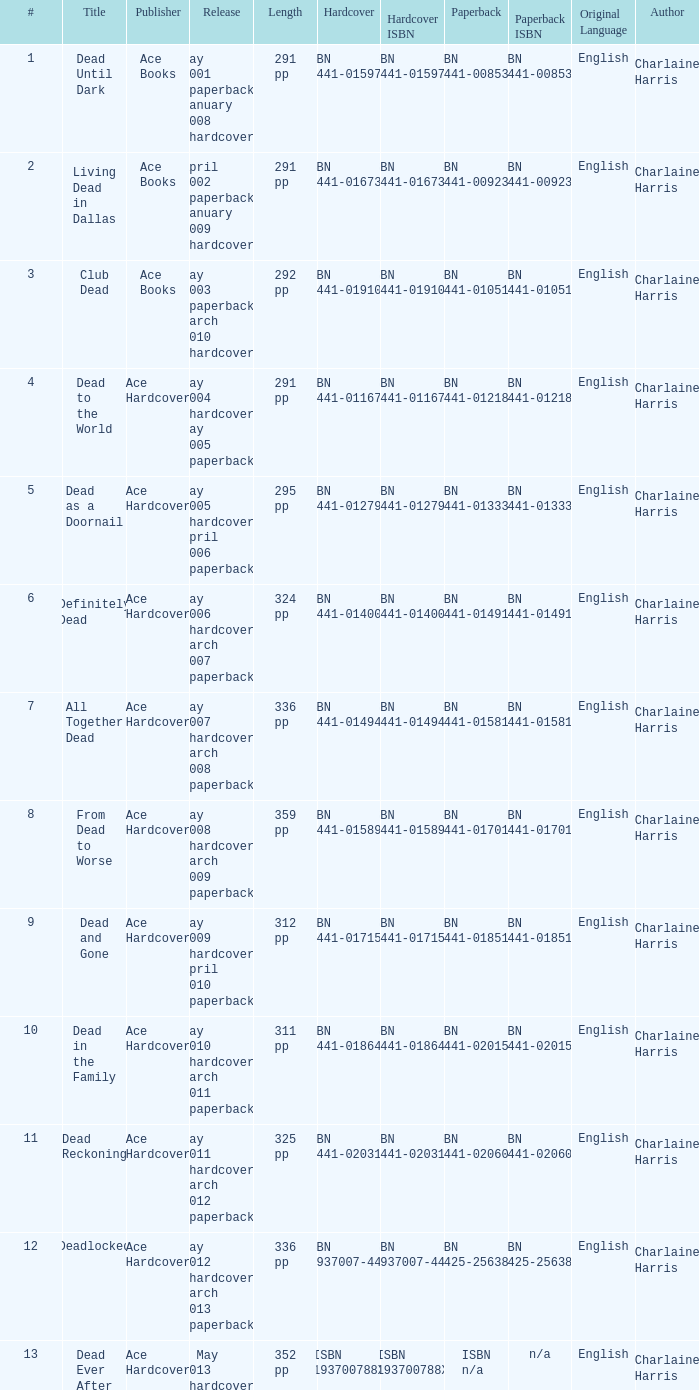What is the ISBN of "Dead as a Doornail? ISBN 0-441-01333-3. 